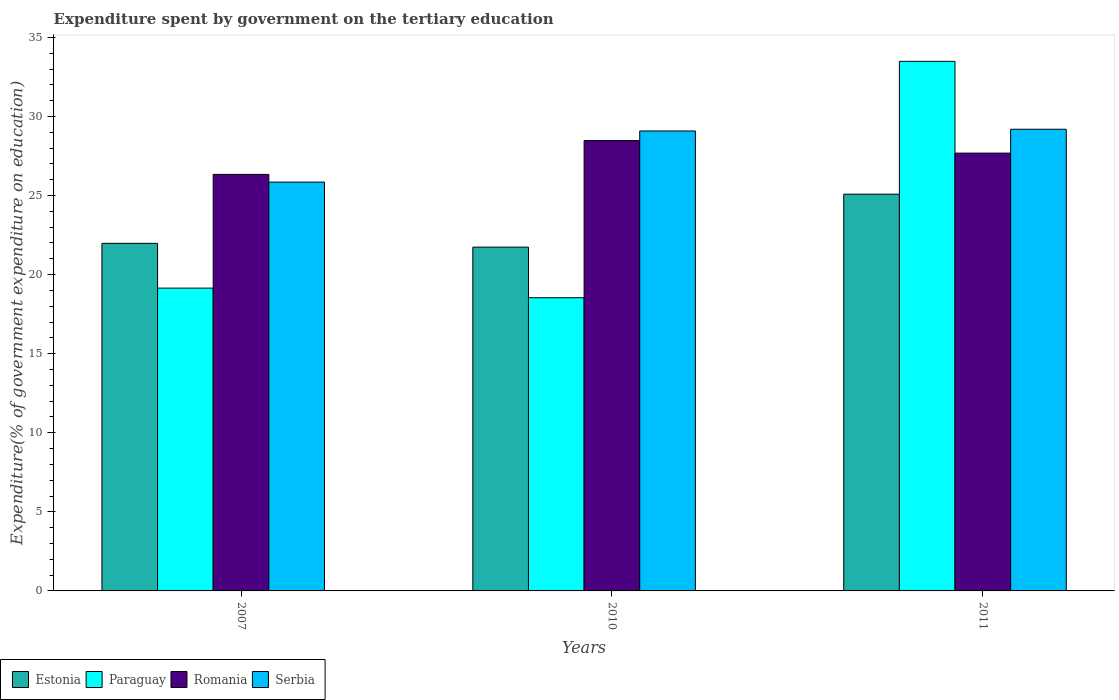How many different coloured bars are there?
Make the answer very short. 4. How many bars are there on the 3rd tick from the right?
Make the answer very short. 4. In how many cases, is the number of bars for a given year not equal to the number of legend labels?
Ensure brevity in your answer.  0. What is the expenditure spent by government on the tertiary education in Romania in 2007?
Provide a short and direct response. 26.33. Across all years, what is the maximum expenditure spent by government on the tertiary education in Estonia?
Your response must be concise. 25.09. Across all years, what is the minimum expenditure spent by government on the tertiary education in Serbia?
Give a very brief answer. 25.85. What is the total expenditure spent by government on the tertiary education in Estonia in the graph?
Provide a succinct answer. 68.8. What is the difference between the expenditure spent by government on the tertiary education in Estonia in 2007 and that in 2011?
Keep it short and to the point. -3.11. What is the difference between the expenditure spent by government on the tertiary education in Paraguay in 2007 and the expenditure spent by government on the tertiary education in Romania in 2010?
Offer a very short reply. -9.33. What is the average expenditure spent by government on the tertiary education in Estonia per year?
Make the answer very short. 22.93. In the year 2010, what is the difference between the expenditure spent by government on the tertiary education in Serbia and expenditure spent by government on the tertiary education in Estonia?
Offer a terse response. 7.34. What is the ratio of the expenditure spent by government on the tertiary education in Romania in 2010 to that in 2011?
Your answer should be compact. 1.03. Is the expenditure spent by government on the tertiary education in Paraguay in 2010 less than that in 2011?
Give a very brief answer. Yes. What is the difference between the highest and the second highest expenditure spent by government on the tertiary education in Paraguay?
Your response must be concise. 14.34. What is the difference between the highest and the lowest expenditure spent by government on the tertiary education in Estonia?
Your answer should be compact. 3.35. In how many years, is the expenditure spent by government on the tertiary education in Serbia greater than the average expenditure spent by government on the tertiary education in Serbia taken over all years?
Your response must be concise. 2. Is it the case that in every year, the sum of the expenditure spent by government on the tertiary education in Paraguay and expenditure spent by government on the tertiary education in Serbia is greater than the sum of expenditure spent by government on the tertiary education in Romania and expenditure spent by government on the tertiary education in Estonia?
Provide a short and direct response. Yes. What does the 3rd bar from the left in 2010 represents?
Keep it short and to the point. Romania. What does the 4th bar from the right in 2007 represents?
Provide a short and direct response. Estonia. Is it the case that in every year, the sum of the expenditure spent by government on the tertiary education in Paraguay and expenditure spent by government on the tertiary education in Romania is greater than the expenditure spent by government on the tertiary education in Estonia?
Ensure brevity in your answer.  Yes. How many years are there in the graph?
Give a very brief answer. 3. What is the difference between two consecutive major ticks on the Y-axis?
Your answer should be very brief. 5. How many legend labels are there?
Provide a short and direct response. 4. What is the title of the graph?
Offer a very short reply. Expenditure spent by government on the tertiary education. What is the label or title of the X-axis?
Keep it short and to the point. Years. What is the label or title of the Y-axis?
Give a very brief answer. Expenditure(% of government expenditure on education). What is the Expenditure(% of government expenditure on education) in Estonia in 2007?
Provide a succinct answer. 21.98. What is the Expenditure(% of government expenditure on education) of Paraguay in 2007?
Make the answer very short. 19.15. What is the Expenditure(% of government expenditure on education) of Romania in 2007?
Ensure brevity in your answer.  26.33. What is the Expenditure(% of government expenditure on education) of Serbia in 2007?
Offer a terse response. 25.85. What is the Expenditure(% of government expenditure on education) of Estonia in 2010?
Your answer should be compact. 21.74. What is the Expenditure(% of government expenditure on education) of Paraguay in 2010?
Ensure brevity in your answer.  18.54. What is the Expenditure(% of government expenditure on education) in Romania in 2010?
Offer a very short reply. 28.47. What is the Expenditure(% of government expenditure on education) of Serbia in 2010?
Make the answer very short. 29.08. What is the Expenditure(% of government expenditure on education) of Estonia in 2011?
Your answer should be compact. 25.09. What is the Expenditure(% of government expenditure on education) in Paraguay in 2011?
Provide a succinct answer. 33.48. What is the Expenditure(% of government expenditure on education) in Romania in 2011?
Give a very brief answer. 27.68. What is the Expenditure(% of government expenditure on education) in Serbia in 2011?
Offer a terse response. 29.19. Across all years, what is the maximum Expenditure(% of government expenditure on education) in Estonia?
Offer a very short reply. 25.09. Across all years, what is the maximum Expenditure(% of government expenditure on education) of Paraguay?
Ensure brevity in your answer.  33.48. Across all years, what is the maximum Expenditure(% of government expenditure on education) of Romania?
Make the answer very short. 28.47. Across all years, what is the maximum Expenditure(% of government expenditure on education) in Serbia?
Provide a short and direct response. 29.19. Across all years, what is the minimum Expenditure(% of government expenditure on education) of Estonia?
Give a very brief answer. 21.74. Across all years, what is the minimum Expenditure(% of government expenditure on education) in Paraguay?
Give a very brief answer. 18.54. Across all years, what is the minimum Expenditure(% of government expenditure on education) in Romania?
Provide a short and direct response. 26.33. Across all years, what is the minimum Expenditure(% of government expenditure on education) of Serbia?
Keep it short and to the point. 25.85. What is the total Expenditure(% of government expenditure on education) of Estonia in the graph?
Make the answer very short. 68.8. What is the total Expenditure(% of government expenditure on education) of Paraguay in the graph?
Offer a terse response. 71.17. What is the total Expenditure(% of government expenditure on education) in Romania in the graph?
Give a very brief answer. 82.49. What is the total Expenditure(% of government expenditure on education) in Serbia in the graph?
Make the answer very short. 84.12. What is the difference between the Expenditure(% of government expenditure on education) in Estonia in 2007 and that in 2010?
Your answer should be very brief. 0.24. What is the difference between the Expenditure(% of government expenditure on education) of Paraguay in 2007 and that in 2010?
Give a very brief answer. 0.61. What is the difference between the Expenditure(% of government expenditure on education) in Romania in 2007 and that in 2010?
Ensure brevity in your answer.  -2.14. What is the difference between the Expenditure(% of government expenditure on education) in Serbia in 2007 and that in 2010?
Keep it short and to the point. -3.23. What is the difference between the Expenditure(% of government expenditure on education) in Estonia in 2007 and that in 2011?
Offer a terse response. -3.11. What is the difference between the Expenditure(% of government expenditure on education) in Paraguay in 2007 and that in 2011?
Your response must be concise. -14.34. What is the difference between the Expenditure(% of government expenditure on education) of Romania in 2007 and that in 2011?
Your answer should be compact. -1.35. What is the difference between the Expenditure(% of government expenditure on education) in Serbia in 2007 and that in 2011?
Make the answer very short. -3.34. What is the difference between the Expenditure(% of government expenditure on education) of Estonia in 2010 and that in 2011?
Keep it short and to the point. -3.35. What is the difference between the Expenditure(% of government expenditure on education) of Paraguay in 2010 and that in 2011?
Offer a very short reply. -14.95. What is the difference between the Expenditure(% of government expenditure on education) of Romania in 2010 and that in 2011?
Provide a short and direct response. 0.79. What is the difference between the Expenditure(% of government expenditure on education) of Serbia in 2010 and that in 2011?
Offer a terse response. -0.11. What is the difference between the Expenditure(% of government expenditure on education) of Estonia in 2007 and the Expenditure(% of government expenditure on education) of Paraguay in 2010?
Make the answer very short. 3.44. What is the difference between the Expenditure(% of government expenditure on education) in Estonia in 2007 and the Expenditure(% of government expenditure on education) in Romania in 2010?
Offer a very short reply. -6.5. What is the difference between the Expenditure(% of government expenditure on education) of Estonia in 2007 and the Expenditure(% of government expenditure on education) of Serbia in 2010?
Make the answer very short. -7.11. What is the difference between the Expenditure(% of government expenditure on education) in Paraguay in 2007 and the Expenditure(% of government expenditure on education) in Romania in 2010?
Your answer should be very brief. -9.33. What is the difference between the Expenditure(% of government expenditure on education) of Paraguay in 2007 and the Expenditure(% of government expenditure on education) of Serbia in 2010?
Make the answer very short. -9.94. What is the difference between the Expenditure(% of government expenditure on education) in Romania in 2007 and the Expenditure(% of government expenditure on education) in Serbia in 2010?
Make the answer very short. -2.75. What is the difference between the Expenditure(% of government expenditure on education) of Estonia in 2007 and the Expenditure(% of government expenditure on education) of Paraguay in 2011?
Give a very brief answer. -11.51. What is the difference between the Expenditure(% of government expenditure on education) in Estonia in 2007 and the Expenditure(% of government expenditure on education) in Romania in 2011?
Offer a terse response. -5.71. What is the difference between the Expenditure(% of government expenditure on education) of Estonia in 2007 and the Expenditure(% of government expenditure on education) of Serbia in 2011?
Your answer should be compact. -7.21. What is the difference between the Expenditure(% of government expenditure on education) in Paraguay in 2007 and the Expenditure(% of government expenditure on education) in Romania in 2011?
Provide a short and direct response. -8.54. What is the difference between the Expenditure(% of government expenditure on education) in Paraguay in 2007 and the Expenditure(% of government expenditure on education) in Serbia in 2011?
Make the answer very short. -10.04. What is the difference between the Expenditure(% of government expenditure on education) of Romania in 2007 and the Expenditure(% of government expenditure on education) of Serbia in 2011?
Provide a succinct answer. -2.86. What is the difference between the Expenditure(% of government expenditure on education) in Estonia in 2010 and the Expenditure(% of government expenditure on education) in Paraguay in 2011?
Your response must be concise. -11.75. What is the difference between the Expenditure(% of government expenditure on education) in Estonia in 2010 and the Expenditure(% of government expenditure on education) in Romania in 2011?
Offer a terse response. -5.94. What is the difference between the Expenditure(% of government expenditure on education) of Estonia in 2010 and the Expenditure(% of government expenditure on education) of Serbia in 2011?
Offer a terse response. -7.45. What is the difference between the Expenditure(% of government expenditure on education) in Paraguay in 2010 and the Expenditure(% of government expenditure on education) in Romania in 2011?
Make the answer very short. -9.14. What is the difference between the Expenditure(% of government expenditure on education) of Paraguay in 2010 and the Expenditure(% of government expenditure on education) of Serbia in 2011?
Give a very brief answer. -10.65. What is the difference between the Expenditure(% of government expenditure on education) of Romania in 2010 and the Expenditure(% of government expenditure on education) of Serbia in 2011?
Make the answer very short. -0.72. What is the average Expenditure(% of government expenditure on education) in Estonia per year?
Provide a short and direct response. 22.93. What is the average Expenditure(% of government expenditure on education) of Paraguay per year?
Your response must be concise. 23.72. What is the average Expenditure(% of government expenditure on education) of Romania per year?
Keep it short and to the point. 27.5. What is the average Expenditure(% of government expenditure on education) in Serbia per year?
Your answer should be very brief. 28.04. In the year 2007, what is the difference between the Expenditure(% of government expenditure on education) in Estonia and Expenditure(% of government expenditure on education) in Paraguay?
Make the answer very short. 2.83. In the year 2007, what is the difference between the Expenditure(% of government expenditure on education) in Estonia and Expenditure(% of government expenditure on education) in Romania?
Offer a terse response. -4.36. In the year 2007, what is the difference between the Expenditure(% of government expenditure on education) of Estonia and Expenditure(% of government expenditure on education) of Serbia?
Ensure brevity in your answer.  -3.87. In the year 2007, what is the difference between the Expenditure(% of government expenditure on education) of Paraguay and Expenditure(% of government expenditure on education) of Romania?
Your answer should be very brief. -7.19. In the year 2007, what is the difference between the Expenditure(% of government expenditure on education) of Paraguay and Expenditure(% of government expenditure on education) of Serbia?
Keep it short and to the point. -6.7. In the year 2007, what is the difference between the Expenditure(% of government expenditure on education) in Romania and Expenditure(% of government expenditure on education) in Serbia?
Keep it short and to the point. 0.49. In the year 2010, what is the difference between the Expenditure(% of government expenditure on education) in Estonia and Expenditure(% of government expenditure on education) in Paraguay?
Offer a very short reply. 3.2. In the year 2010, what is the difference between the Expenditure(% of government expenditure on education) in Estonia and Expenditure(% of government expenditure on education) in Romania?
Provide a succinct answer. -6.74. In the year 2010, what is the difference between the Expenditure(% of government expenditure on education) in Estonia and Expenditure(% of government expenditure on education) in Serbia?
Keep it short and to the point. -7.34. In the year 2010, what is the difference between the Expenditure(% of government expenditure on education) of Paraguay and Expenditure(% of government expenditure on education) of Romania?
Ensure brevity in your answer.  -9.94. In the year 2010, what is the difference between the Expenditure(% of government expenditure on education) in Paraguay and Expenditure(% of government expenditure on education) in Serbia?
Provide a succinct answer. -10.54. In the year 2010, what is the difference between the Expenditure(% of government expenditure on education) in Romania and Expenditure(% of government expenditure on education) in Serbia?
Keep it short and to the point. -0.61. In the year 2011, what is the difference between the Expenditure(% of government expenditure on education) in Estonia and Expenditure(% of government expenditure on education) in Paraguay?
Make the answer very short. -8.4. In the year 2011, what is the difference between the Expenditure(% of government expenditure on education) in Estonia and Expenditure(% of government expenditure on education) in Romania?
Provide a succinct answer. -2.6. In the year 2011, what is the difference between the Expenditure(% of government expenditure on education) in Estonia and Expenditure(% of government expenditure on education) in Serbia?
Offer a terse response. -4.1. In the year 2011, what is the difference between the Expenditure(% of government expenditure on education) in Paraguay and Expenditure(% of government expenditure on education) in Romania?
Offer a terse response. 5.8. In the year 2011, what is the difference between the Expenditure(% of government expenditure on education) in Paraguay and Expenditure(% of government expenditure on education) in Serbia?
Your response must be concise. 4.29. In the year 2011, what is the difference between the Expenditure(% of government expenditure on education) in Romania and Expenditure(% of government expenditure on education) in Serbia?
Give a very brief answer. -1.51. What is the ratio of the Expenditure(% of government expenditure on education) of Paraguay in 2007 to that in 2010?
Offer a terse response. 1.03. What is the ratio of the Expenditure(% of government expenditure on education) of Romania in 2007 to that in 2010?
Provide a succinct answer. 0.92. What is the ratio of the Expenditure(% of government expenditure on education) of Serbia in 2007 to that in 2010?
Your response must be concise. 0.89. What is the ratio of the Expenditure(% of government expenditure on education) of Estonia in 2007 to that in 2011?
Your answer should be compact. 0.88. What is the ratio of the Expenditure(% of government expenditure on education) of Paraguay in 2007 to that in 2011?
Provide a short and direct response. 0.57. What is the ratio of the Expenditure(% of government expenditure on education) of Romania in 2007 to that in 2011?
Provide a short and direct response. 0.95. What is the ratio of the Expenditure(% of government expenditure on education) of Serbia in 2007 to that in 2011?
Provide a short and direct response. 0.89. What is the ratio of the Expenditure(% of government expenditure on education) in Estonia in 2010 to that in 2011?
Ensure brevity in your answer.  0.87. What is the ratio of the Expenditure(% of government expenditure on education) in Paraguay in 2010 to that in 2011?
Your response must be concise. 0.55. What is the ratio of the Expenditure(% of government expenditure on education) in Romania in 2010 to that in 2011?
Keep it short and to the point. 1.03. What is the difference between the highest and the second highest Expenditure(% of government expenditure on education) in Estonia?
Your answer should be very brief. 3.11. What is the difference between the highest and the second highest Expenditure(% of government expenditure on education) in Paraguay?
Give a very brief answer. 14.34. What is the difference between the highest and the second highest Expenditure(% of government expenditure on education) of Romania?
Offer a very short reply. 0.79. What is the difference between the highest and the second highest Expenditure(% of government expenditure on education) in Serbia?
Your answer should be compact. 0.11. What is the difference between the highest and the lowest Expenditure(% of government expenditure on education) in Estonia?
Offer a terse response. 3.35. What is the difference between the highest and the lowest Expenditure(% of government expenditure on education) in Paraguay?
Your answer should be compact. 14.95. What is the difference between the highest and the lowest Expenditure(% of government expenditure on education) of Romania?
Offer a very short reply. 2.14. What is the difference between the highest and the lowest Expenditure(% of government expenditure on education) in Serbia?
Offer a terse response. 3.34. 